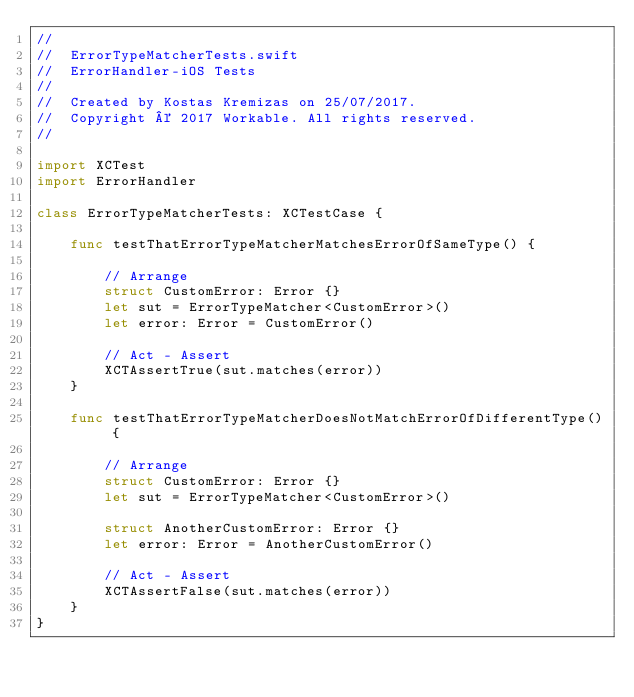Convert code to text. <code><loc_0><loc_0><loc_500><loc_500><_Swift_>//
//  ErrorTypeMatcherTests.swift
//  ErrorHandler-iOS Tests
//
//  Created by Kostas Kremizas on 25/07/2017.
//  Copyright © 2017 Workable. All rights reserved.
//

import XCTest
import ErrorHandler

class ErrorTypeMatcherTests: XCTestCase {
    
    func testThatErrorTypeMatcherMatchesErrorOfSameType() {
        
        // Arrange
        struct CustomError: Error {}
        let sut = ErrorTypeMatcher<CustomError>()
        let error: Error = CustomError()
        
        // Act - Assert
        XCTAssertTrue(sut.matches(error))
    }
    
    func testThatErrorTypeMatcherDoesNotMatchErrorOfDifferentType() {
        
        // Arrange
        struct CustomError: Error {}
        let sut = ErrorTypeMatcher<CustomError>()
        
        struct AnotherCustomError: Error {}
        let error: Error = AnotherCustomError()
        
        // Act - Assert
        XCTAssertFalse(sut.matches(error))
    }
}
</code> 